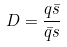<formula> <loc_0><loc_0><loc_500><loc_500>D = \frac { q \bar { s } } { \bar { q } s }</formula> 